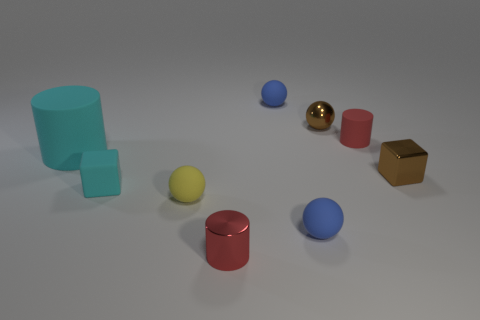The cyan cylinder has what size?
Your answer should be compact. Large. Do the brown object in front of the red rubber thing and the blue rubber thing behind the tiny cyan matte cube have the same size?
Offer a very short reply. Yes. The other matte object that is the same shape as the tiny red rubber object is what size?
Make the answer very short. Large. Is the size of the red shiny thing the same as the rubber cylinder to the left of the metal ball?
Ensure brevity in your answer.  No. There is a small cylinder behind the red shiny cylinder; are there any brown things behind it?
Your answer should be compact. Yes. The small brown thing that is behind the tiny red rubber object has what shape?
Ensure brevity in your answer.  Sphere. What material is the block that is the same color as the small metallic ball?
Ensure brevity in your answer.  Metal. The ball that is to the left of the rubber ball that is behind the yellow matte thing is what color?
Give a very brief answer. Yellow. Do the metal cube and the cyan cylinder have the same size?
Your answer should be very brief. No. There is another red object that is the same shape as the red metal object; what is it made of?
Provide a short and direct response. Rubber. 